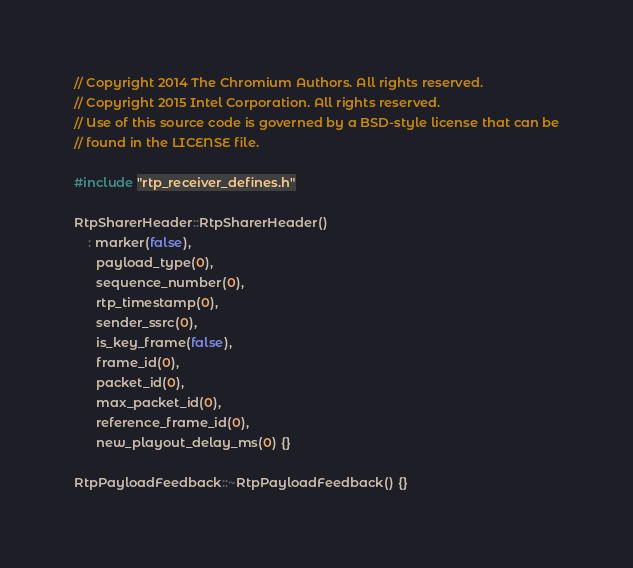<code> <loc_0><loc_0><loc_500><loc_500><_C++_>// Copyright 2014 The Chromium Authors. All rights reserved.
// Copyright 2015 Intel Corporation. All rights reserved.
// Use of this source code is governed by a BSD-style license that can be
// found in the LICENSE file.

#include "rtp_receiver_defines.h"

RtpSharerHeader::RtpSharerHeader()
    : marker(false),
      payload_type(0),
      sequence_number(0),
      rtp_timestamp(0),
      sender_ssrc(0),
      is_key_frame(false),
      frame_id(0),
      packet_id(0),
      max_packet_id(0),
      reference_frame_id(0),
      new_playout_delay_ms(0) {}

RtpPayloadFeedback::~RtpPayloadFeedback() {}
</code> 